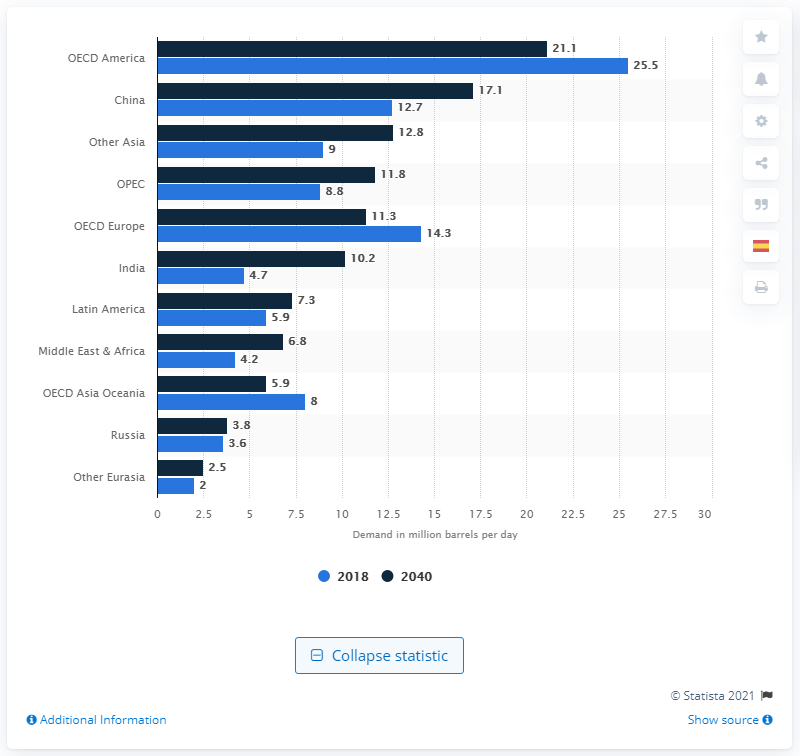Point out several critical features in this image. China is the country that consumes the most oil per day among all countries. 